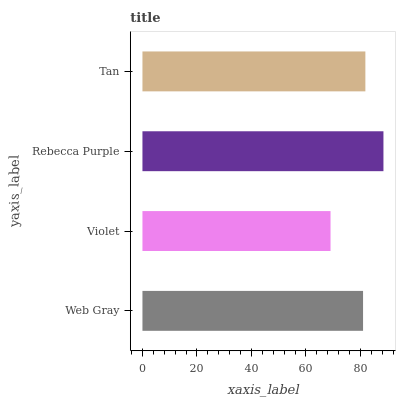Is Violet the minimum?
Answer yes or no. Yes. Is Rebecca Purple the maximum?
Answer yes or no. Yes. Is Rebecca Purple the minimum?
Answer yes or no. No. Is Violet the maximum?
Answer yes or no. No. Is Rebecca Purple greater than Violet?
Answer yes or no. Yes. Is Violet less than Rebecca Purple?
Answer yes or no. Yes. Is Violet greater than Rebecca Purple?
Answer yes or no. No. Is Rebecca Purple less than Violet?
Answer yes or no. No. Is Tan the high median?
Answer yes or no. Yes. Is Web Gray the low median?
Answer yes or no. Yes. Is Web Gray the high median?
Answer yes or no. No. Is Tan the low median?
Answer yes or no. No. 